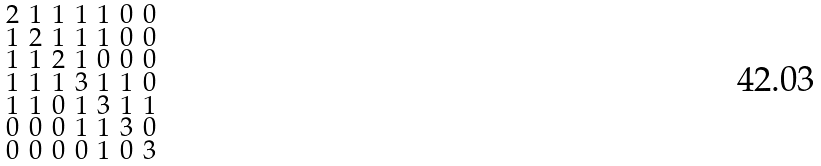Convert formula to latex. <formula><loc_0><loc_0><loc_500><loc_500>\begin{smallmatrix} 2 & 1 & 1 & 1 & 1 & 0 & 0 \\ 1 & 2 & 1 & 1 & 1 & 0 & 0 \\ 1 & 1 & 2 & 1 & 0 & 0 & 0 \\ 1 & 1 & 1 & 3 & 1 & 1 & 0 \\ 1 & 1 & 0 & 1 & 3 & 1 & 1 \\ 0 & 0 & 0 & 1 & 1 & 3 & 0 \\ 0 & 0 & 0 & 0 & 1 & 0 & 3 \end{smallmatrix}</formula> 